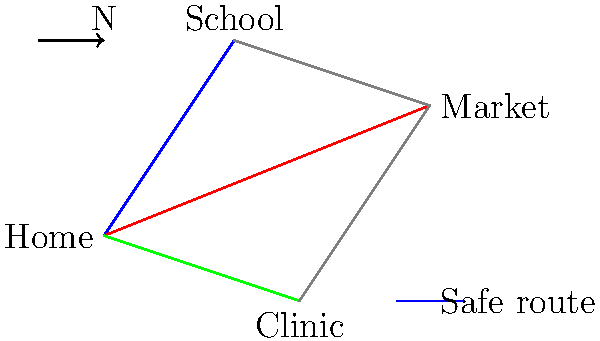Based on the map provided, which route from Home to the Clinic is considered the safest for the refugee family to travel? To determine the safest route from Home to the Clinic, we need to follow these steps:

1. Identify the locations on the map:
   - Home is located at the left side of the map
   - Clinic is located at the bottom of the map
   - School and Market are also shown on the map

2. Observe the different routes:
   - There are three direct routes from Home: to School (blue), to Market (red), and to Clinic (green)
   - There are also indirect routes connecting School, Market, and Clinic (gray)

3. Check the legend:
   - The legend indicates that the blue route is considered the "Safe route"

4. Analyze the routes to the Clinic:
   - The direct green route from Home to Clinic
   - An indirect route through School or Market

5. Compare the routes:
   - The direct green route is not marked as safe
   - The blue route to School is marked as safe

6. Conclude:
   - The safest route would be to first take the blue route from Home to School
   - Then, follow the gray route from School to Clinic

Therefore, the safest route for the refugee family to travel from Home to the Clinic is the indirect path through the School.
Answer: Home to School to Clinic 